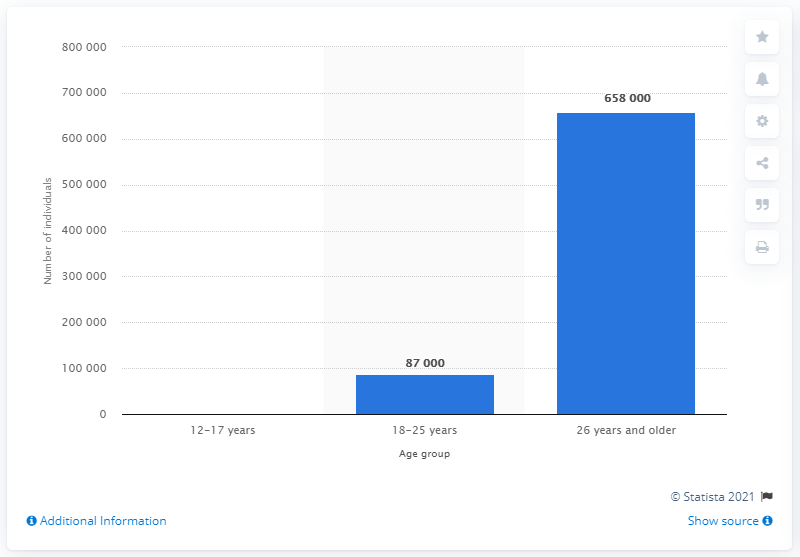Highlight a few significant elements in this photo. In the past year, approximately 658,000 people aged 26 and older consumed heroin, according to data available. 